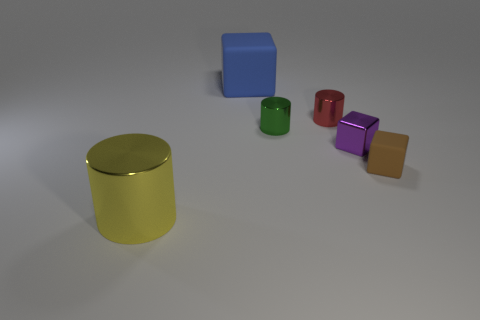Subtract all green cylinders. How many cylinders are left? 2 Subtract all small cylinders. How many cylinders are left? 1 Add 4 tiny matte objects. How many objects exist? 10 Add 1 large blue matte objects. How many large blue matte objects are left? 2 Add 5 tiny cyan metallic cylinders. How many tiny cyan metallic cylinders exist? 5 Subtract 0 gray cubes. How many objects are left? 6 Subtract 1 blocks. How many blocks are left? 2 Subtract all gray cubes. Subtract all green cylinders. How many cubes are left? 3 Subtract all blue blocks. How many yellow cylinders are left? 1 Subtract all big cylinders. Subtract all small brown matte blocks. How many objects are left? 4 